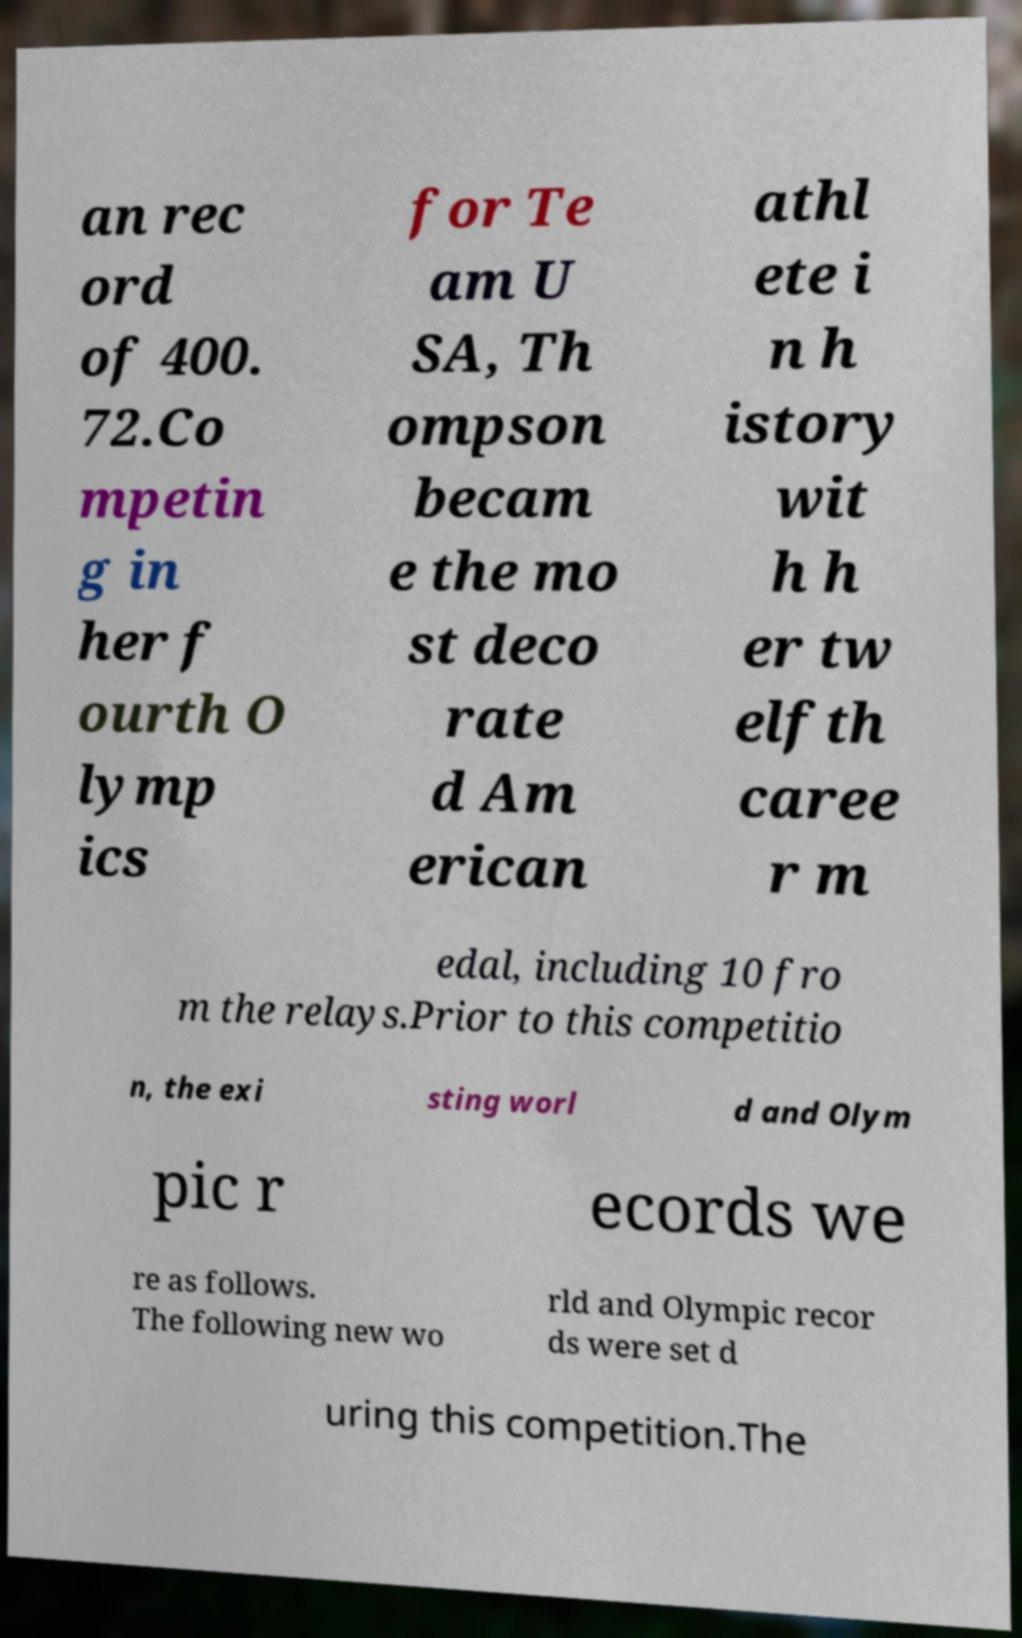Please read and relay the text visible in this image. What does it say? an rec ord of 400. 72.Co mpetin g in her f ourth O lymp ics for Te am U SA, Th ompson becam e the mo st deco rate d Am erican athl ete i n h istory wit h h er tw elfth caree r m edal, including 10 fro m the relays.Prior to this competitio n, the exi sting worl d and Olym pic r ecords we re as follows. The following new wo rld and Olympic recor ds were set d uring this competition.The 